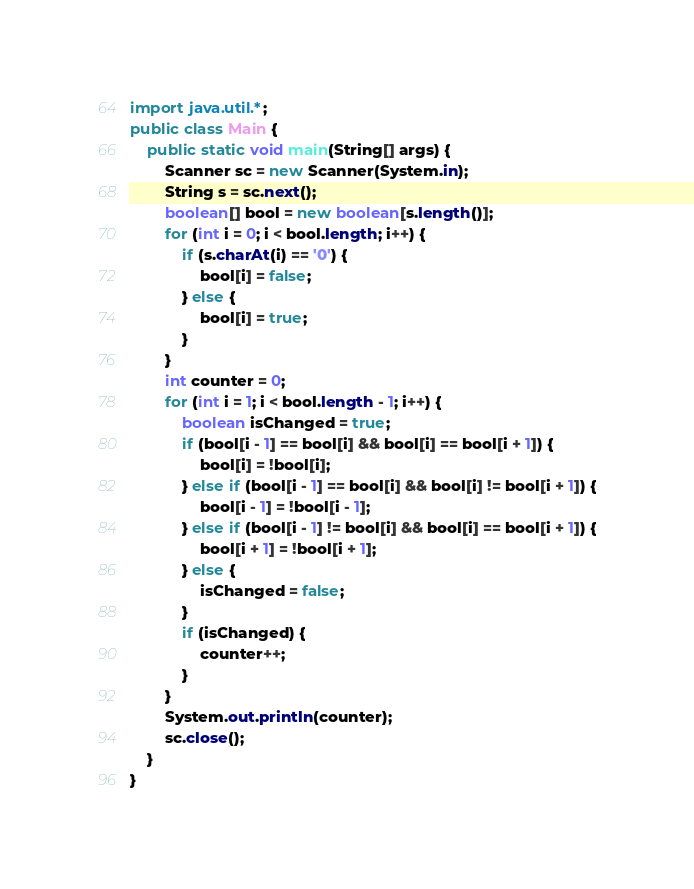Convert code to text. <code><loc_0><loc_0><loc_500><loc_500><_Java_>import java.util.*;
public class Main {
    public static void main(String[] args) {
        Scanner sc = new Scanner(System.in);
        String s = sc.next();
        boolean[] bool = new boolean[s.length()];
        for (int i = 0; i < bool.length; i++) {
            if (s.charAt(i) == '0') {
                bool[i] = false;
            } else {
                bool[i] = true;
            }
        }
        int counter = 0;
        for (int i = 1; i < bool.length - 1; i++) {
            boolean isChanged = true;
            if (bool[i - 1] == bool[i] && bool[i] == bool[i + 1]) {
                bool[i] = !bool[i];
            } else if (bool[i - 1] == bool[i] && bool[i] != bool[i + 1]) {
                bool[i - 1] = !bool[i - 1];
            } else if (bool[i - 1] != bool[i] && bool[i] == bool[i + 1]) {
                bool[i + 1] = !bool[i + 1];
            } else {
                isChanged = false;
            }
            if (isChanged) {
                counter++;
            }
        }
        System.out.println(counter);
        sc.close();
    }
}</code> 